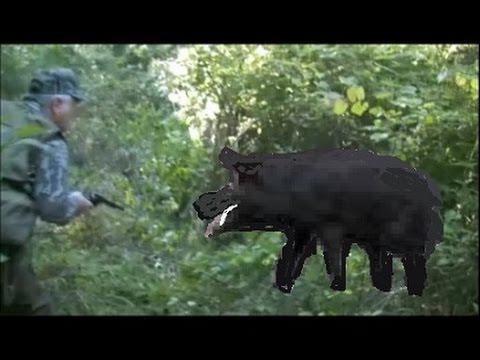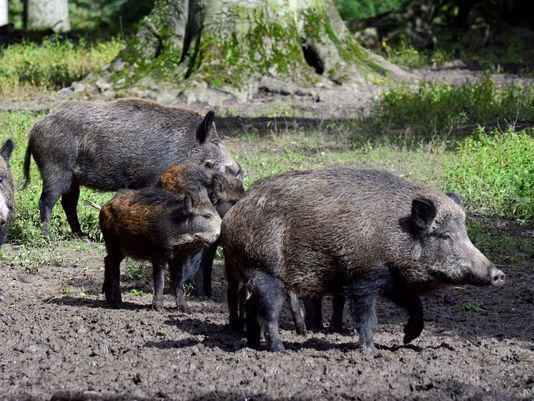The first image is the image on the left, the second image is the image on the right. Assess this claim about the two images: "One wild pig is standing in the grass in the image on the left.". Correct or not? Answer yes or no. Yes. 